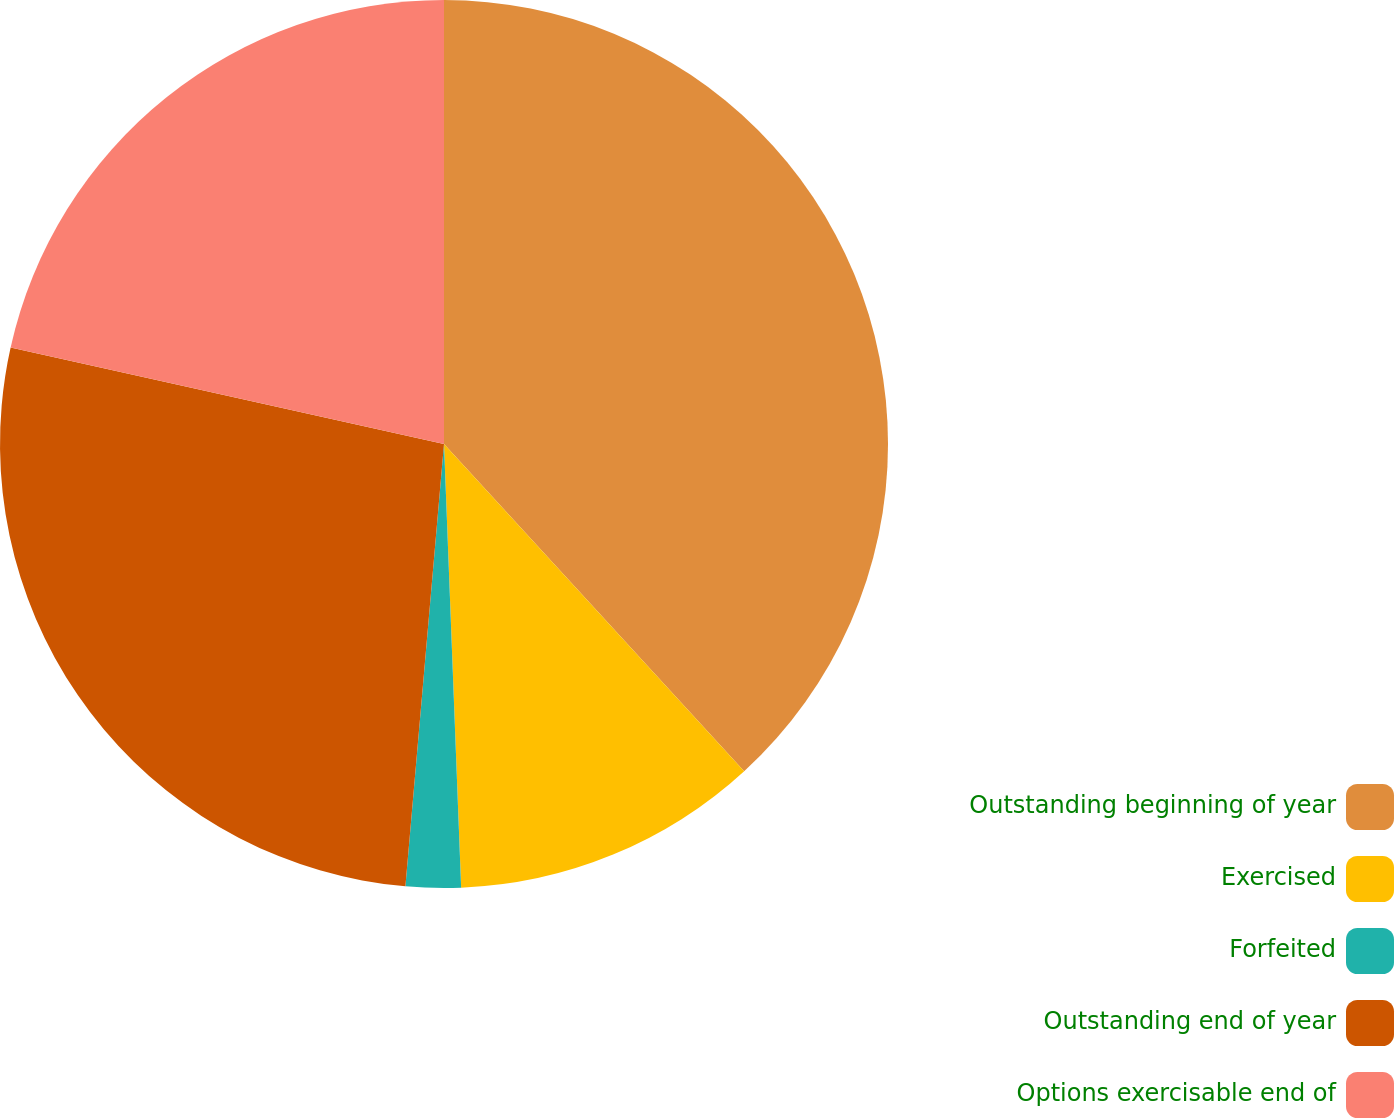<chart> <loc_0><loc_0><loc_500><loc_500><pie_chart><fcel>Outstanding beginning of year<fcel>Exercised<fcel>Forfeited<fcel>Outstanding end of year<fcel>Options exercisable end of<nl><fcel>38.18%<fcel>11.2%<fcel>2.0%<fcel>27.1%<fcel>21.51%<nl></chart> 